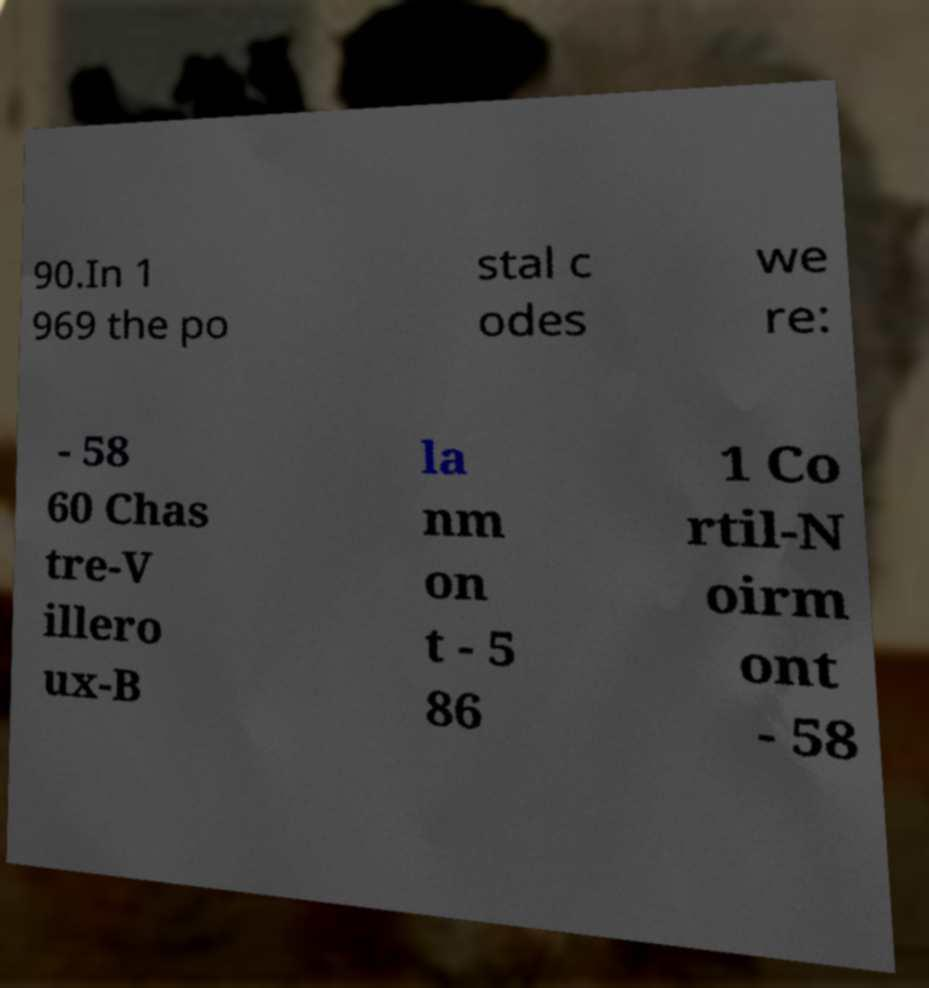Please read and relay the text visible in this image. What does it say? 90.In 1 969 the po stal c odes we re: - 58 60 Chas tre-V illero ux-B la nm on t - 5 86 1 Co rtil-N oirm ont - 58 